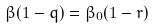Convert formula to latex. <formula><loc_0><loc_0><loc_500><loc_500>\beta ( 1 - q ) = \beta _ { 0 } ( 1 - r )</formula> 